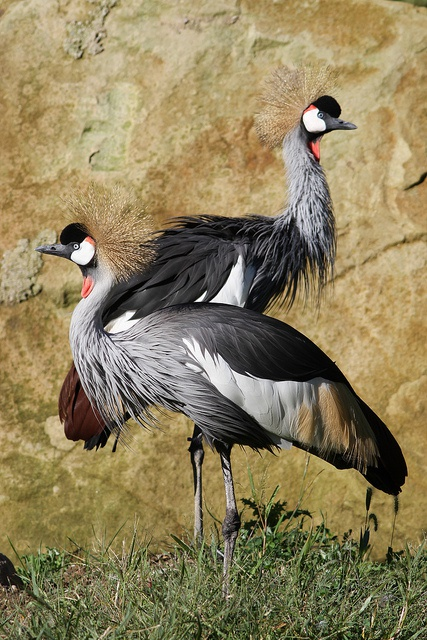Describe the objects in this image and their specific colors. I can see bird in tan, black, darkgray, gray, and lightgray tones and bird in tan, black, gray, and darkgray tones in this image. 